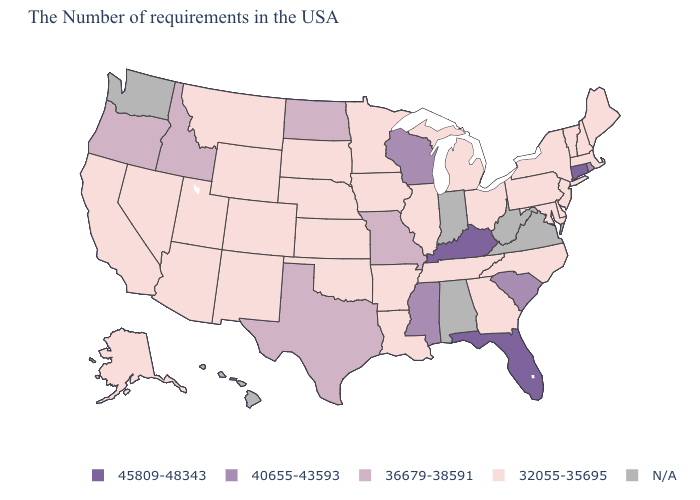Does Texas have the highest value in the USA?
Quick response, please. No. Name the states that have a value in the range N/A?
Keep it brief. Virginia, West Virginia, Indiana, Alabama, Washington, Hawaii. What is the value of Ohio?
Short answer required. 32055-35695. Name the states that have a value in the range 45809-48343?
Quick response, please. Connecticut, Florida, Kentucky. What is the value of Colorado?
Quick response, please. 32055-35695. Does New Jersey have the lowest value in the USA?
Short answer required. Yes. Name the states that have a value in the range 40655-43593?
Short answer required. Rhode Island, South Carolina, Wisconsin, Mississippi. Does Iowa have the lowest value in the USA?
Quick response, please. Yes. Among the states that border South Carolina , which have the highest value?
Short answer required. North Carolina, Georgia. Does the map have missing data?
Concise answer only. Yes. What is the value of Kentucky?
Give a very brief answer. 45809-48343. Does Colorado have the highest value in the West?
Quick response, please. No. Among the states that border North Carolina , does Tennessee have the lowest value?
Quick response, please. Yes. 